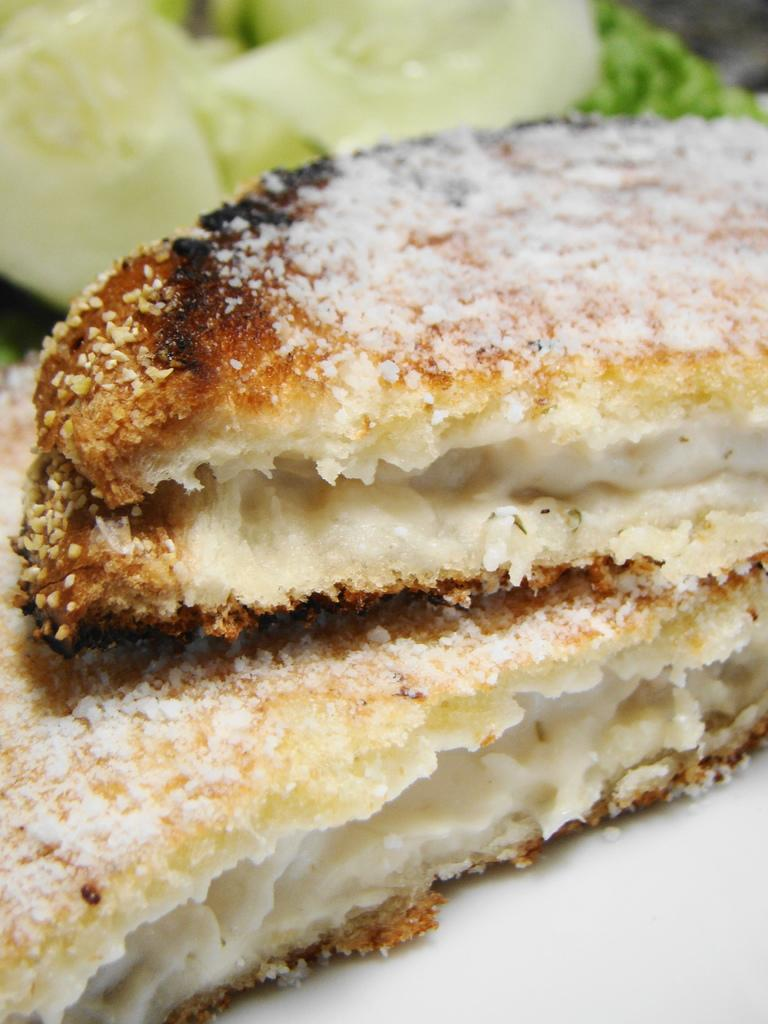What types of items are present in the image? The image contains food items. Where are the food items located in the image? The food items are at the top of the image. What type of punishment is being depicted in the image? There is no punishment being depicted in the image; it contains food items. What day of the week is shown in the image? The image does not depict a specific day of the week; it only contains food items. 